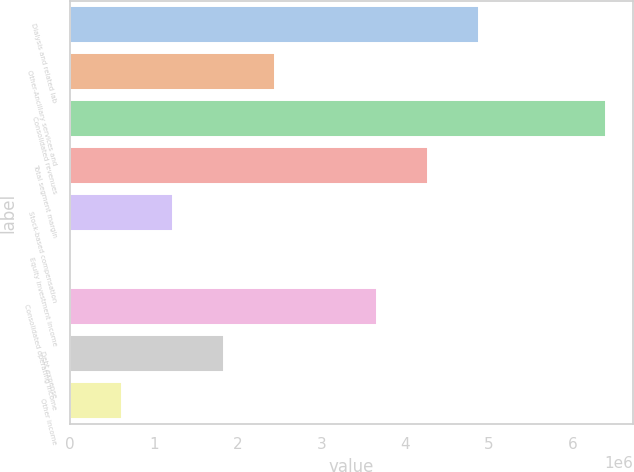<chart> <loc_0><loc_0><loc_500><loc_500><bar_chart><fcel>Dialysis and related lab<fcel>Other-Ancillary services and<fcel>Consolidated revenues<fcel>Total segment margin<fcel>Stock-based compensation<fcel>Equity investment income<fcel>Consolidated operating income<fcel>Debt expense<fcel>Other income<nl><fcel>4.88753e+06<fcel>2.44499e+06<fcel>6.40233e+06<fcel>4.27689e+06<fcel>1.22371e+06<fcel>2442<fcel>3.66626e+06<fcel>1.83435e+06<fcel>613078<nl></chart> 